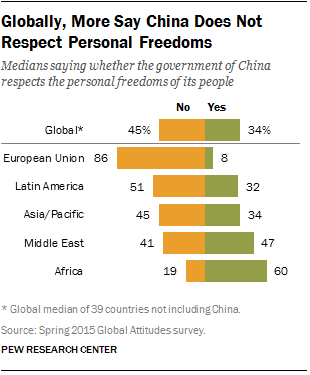Identify some key points in this picture. The green bar represents yes. The ratio between the European Union and Latin America is 1.68. 